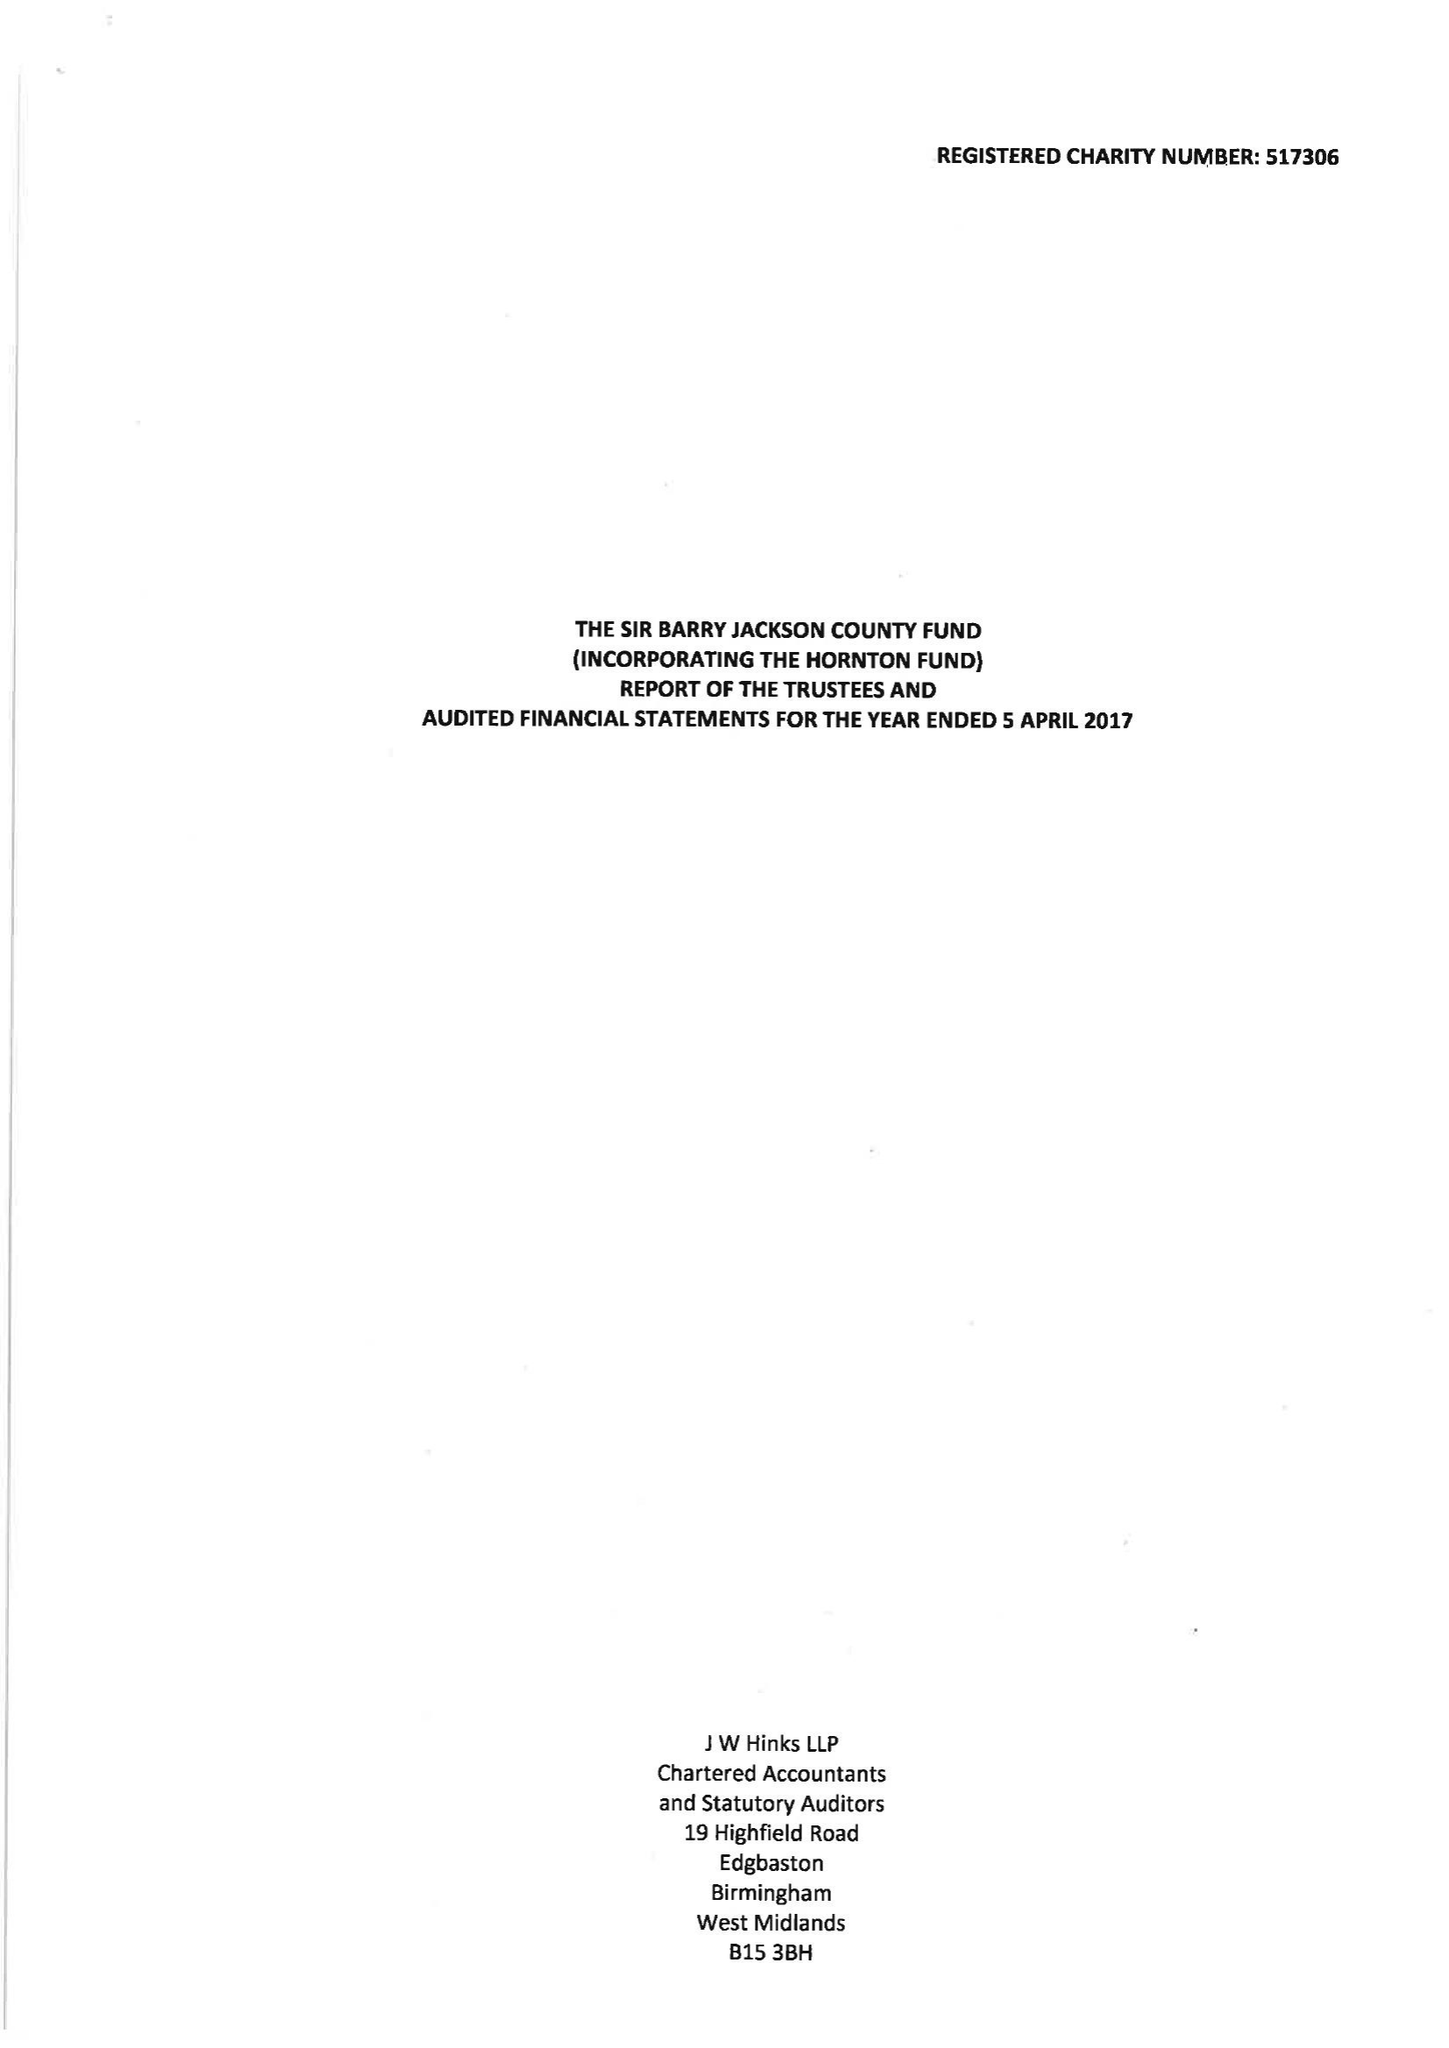What is the value for the charity_name?
Answer the question using a single word or phrase. The Sir Barry Jackson County Fund 